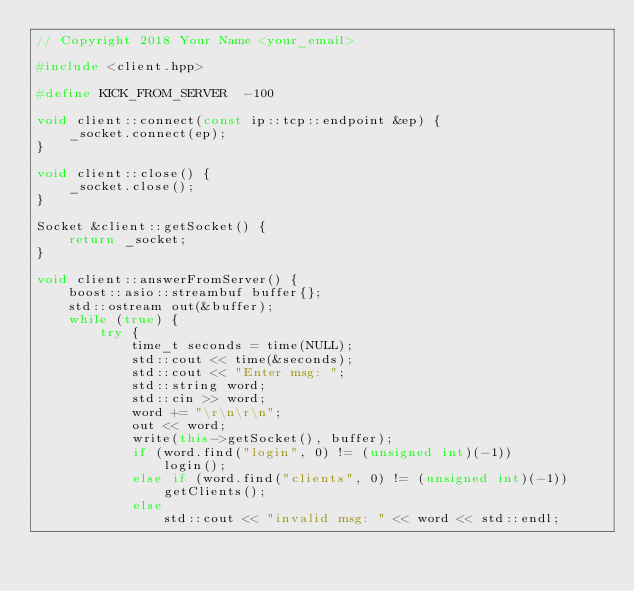<code> <loc_0><loc_0><loc_500><loc_500><_C++_>// Copyright 2018 Your Name <your_email>

#include <client.hpp>

#define KICK_FROM_SERVER  -100

void client::connect(const ip::tcp::endpoint &ep) {
    _socket.connect(ep);
}

void client::close() {
    _socket.close();
}

Socket &client::getSocket() {
    return _socket;
}

void client::answerFromServer() {
    boost::asio::streambuf buffer{};
    std::ostream out(&buffer);
    while (true) {
        try {
            time_t seconds = time(NULL);
            std::cout << time(&seconds);
            std::cout << "Enter msg: ";
            std::string word;
            std::cin >> word;
            word += "\r\n\r\n";
            out << word;
            write(this->getSocket(), buffer);
            if (word.find("login", 0) != (unsigned int)(-1))
                login();
            else if (word.find("clients", 0) != (unsigned int)(-1))
                getClients();
            else
                std::cout << "invalid msg: " << word << std::endl;</code> 